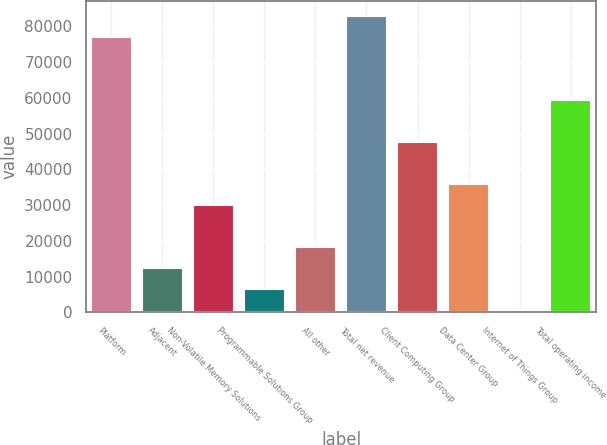<chart> <loc_0><loc_0><loc_500><loc_500><bar_chart><fcel>Platform<fcel>Adjacent<fcel>Non-Volatile Memory Solutions<fcel>Programmable Solutions Group<fcel>All other<fcel>Total net revenue<fcel>Client Computing Group<fcel>Data Center Group<fcel>Internet of Things Group<fcel>Total operating income<nl><fcel>77027.6<fcel>12345.4<fcel>29986<fcel>6465.2<fcel>18225.6<fcel>82907.8<fcel>47626.6<fcel>35866.2<fcel>585<fcel>59387<nl></chart> 